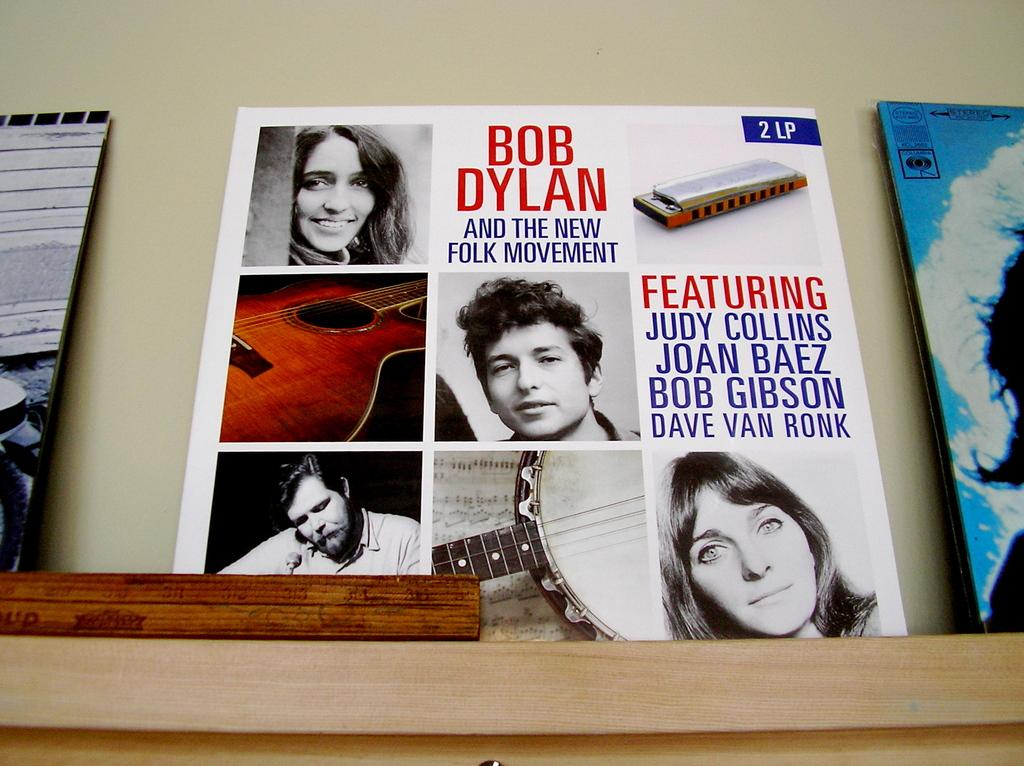Provide a one-sentence caption for the provided image. A Bob Dylan record says it features Judy Collins. 